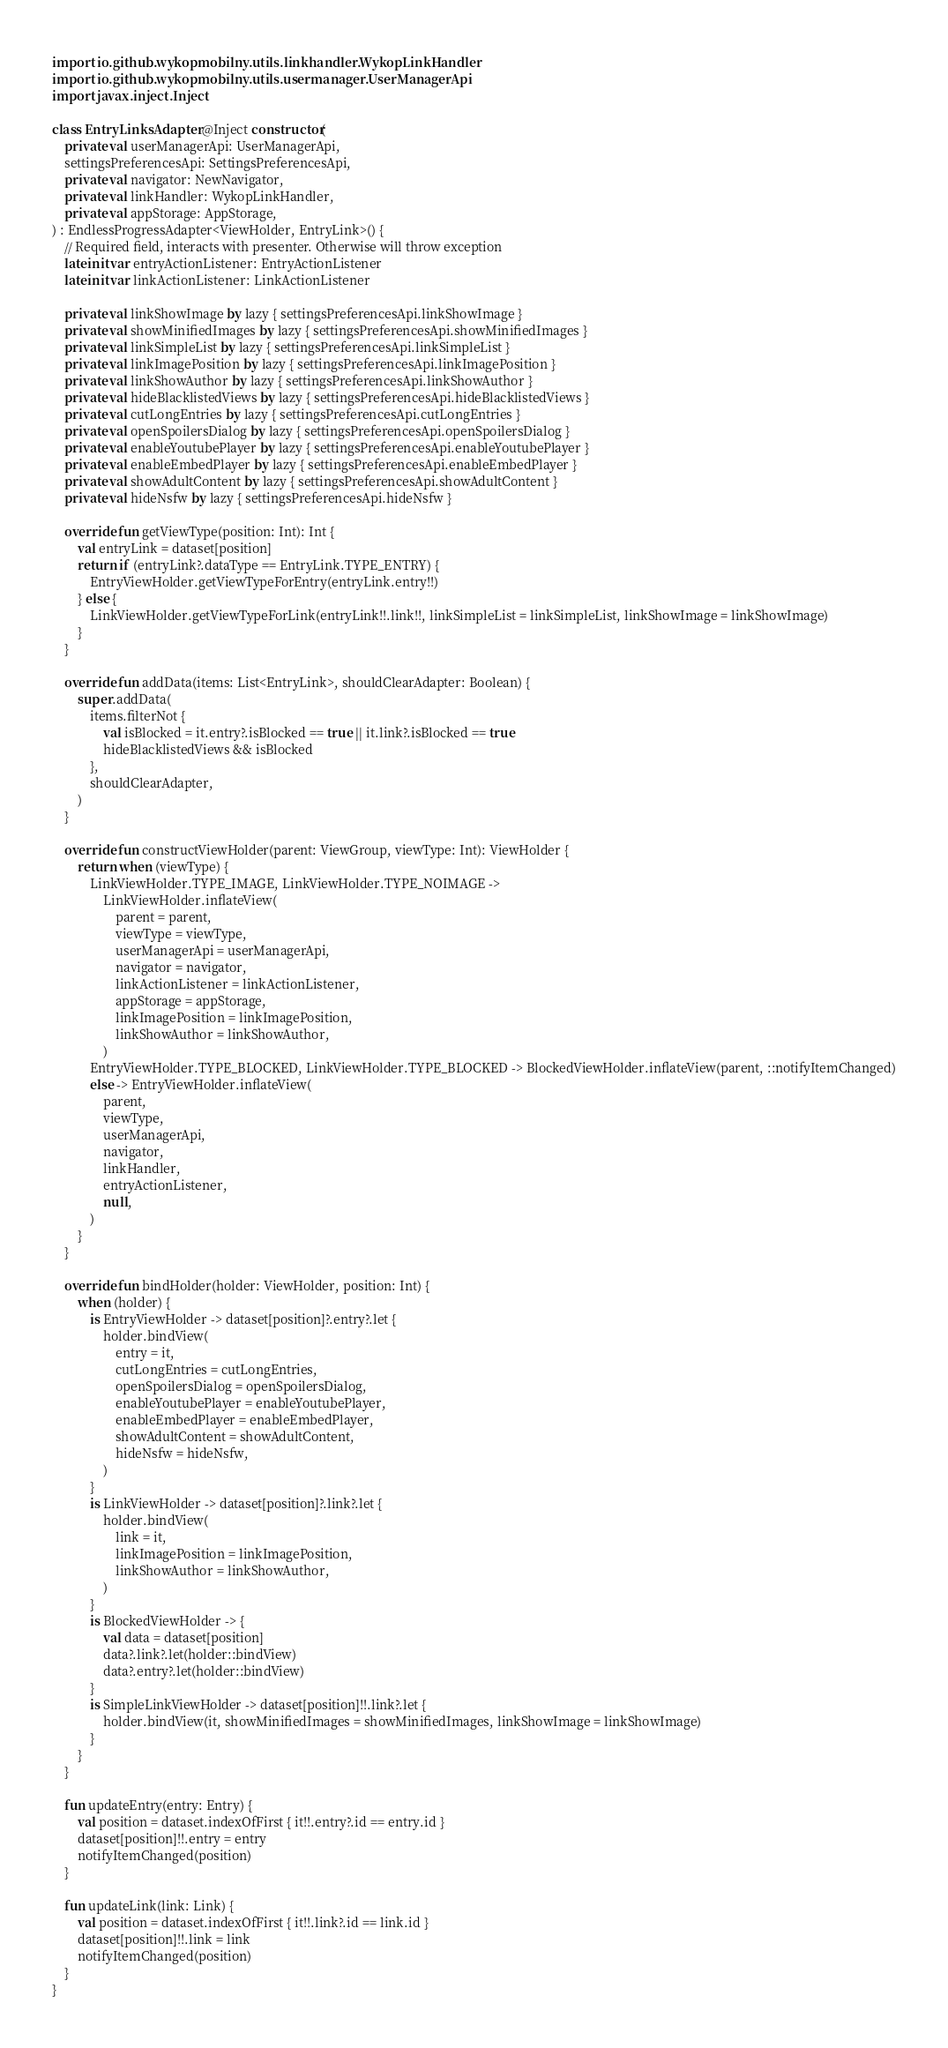Convert code to text. <code><loc_0><loc_0><loc_500><loc_500><_Kotlin_>import io.github.wykopmobilny.utils.linkhandler.WykopLinkHandler
import io.github.wykopmobilny.utils.usermanager.UserManagerApi
import javax.inject.Inject

class EntryLinksAdapter @Inject constructor(
    private val userManagerApi: UserManagerApi,
    settingsPreferencesApi: SettingsPreferencesApi,
    private val navigator: NewNavigator,
    private val linkHandler: WykopLinkHandler,
    private val appStorage: AppStorage,
) : EndlessProgressAdapter<ViewHolder, EntryLink>() {
    // Required field, interacts with presenter. Otherwise will throw exception
    lateinit var entryActionListener: EntryActionListener
    lateinit var linkActionListener: LinkActionListener

    private val linkShowImage by lazy { settingsPreferencesApi.linkShowImage }
    private val showMinifiedImages by lazy { settingsPreferencesApi.showMinifiedImages }
    private val linkSimpleList by lazy { settingsPreferencesApi.linkSimpleList }
    private val linkImagePosition by lazy { settingsPreferencesApi.linkImagePosition }
    private val linkShowAuthor by lazy { settingsPreferencesApi.linkShowAuthor }
    private val hideBlacklistedViews by lazy { settingsPreferencesApi.hideBlacklistedViews }
    private val cutLongEntries by lazy { settingsPreferencesApi.cutLongEntries }
    private val openSpoilersDialog by lazy { settingsPreferencesApi.openSpoilersDialog }
    private val enableYoutubePlayer by lazy { settingsPreferencesApi.enableYoutubePlayer }
    private val enableEmbedPlayer by lazy { settingsPreferencesApi.enableEmbedPlayer }
    private val showAdultContent by lazy { settingsPreferencesApi.showAdultContent }
    private val hideNsfw by lazy { settingsPreferencesApi.hideNsfw }

    override fun getViewType(position: Int): Int {
        val entryLink = dataset[position]
        return if (entryLink?.dataType == EntryLink.TYPE_ENTRY) {
            EntryViewHolder.getViewTypeForEntry(entryLink.entry!!)
        } else {
            LinkViewHolder.getViewTypeForLink(entryLink!!.link!!, linkSimpleList = linkSimpleList, linkShowImage = linkShowImage)
        }
    }

    override fun addData(items: List<EntryLink>, shouldClearAdapter: Boolean) {
        super.addData(
            items.filterNot {
                val isBlocked = it.entry?.isBlocked == true || it.link?.isBlocked == true
                hideBlacklistedViews && isBlocked
            },
            shouldClearAdapter,
        )
    }

    override fun constructViewHolder(parent: ViewGroup, viewType: Int): ViewHolder {
        return when (viewType) {
            LinkViewHolder.TYPE_IMAGE, LinkViewHolder.TYPE_NOIMAGE ->
                LinkViewHolder.inflateView(
                    parent = parent,
                    viewType = viewType,
                    userManagerApi = userManagerApi,
                    navigator = navigator,
                    linkActionListener = linkActionListener,
                    appStorage = appStorage,
                    linkImagePosition = linkImagePosition,
                    linkShowAuthor = linkShowAuthor,
                )
            EntryViewHolder.TYPE_BLOCKED, LinkViewHolder.TYPE_BLOCKED -> BlockedViewHolder.inflateView(parent, ::notifyItemChanged)
            else -> EntryViewHolder.inflateView(
                parent,
                viewType,
                userManagerApi,
                navigator,
                linkHandler,
                entryActionListener,
                null,
            )
        }
    }

    override fun bindHolder(holder: ViewHolder, position: Int) {
        when (holder) {
            is EntryViewHolder -> dataset[position]?.entry?.let {
                holder.bindView(
                    entry = it,
                    cutLongEntries = cutLongEntries,
                    openSpoilersDialog = openSpoilersDialog,
                    enableYoutubePlayer = enableYoutubePlayer,
                    enableEmbedPlayer = enableEmbedPlayer,
                    showAdultContent = showAdultContent,
                    hideNsfw = hideNsfw,
                )
            }
            is LinkViewHolder -> dataset[position]?.link?.let {
                holder.bindView(
                    link = it,
                    linkImagePosition = linkImagePosition,
                    linkShowAuthor = linkShowAuthor,
                )
            }
            is BlockedViewHolder -> {
                val data = dataset[position]
                data?.link?.let(holder::bindView)
                data?.entry?.let(holder::bindView)
            }
            is SimpleLinkViewHolder -> dataset[position]!!.link?.let {
                holder.bindView(it, showMinifiedImages = showMinifiedImages, linkShowImage = linkShowImage)
            }
        }
    }

    fun updateEntry(entry: Entry) {
        val position = dataset.indexOfFirst { it!!.entry?.id == entry.id }
        dataset[position]!!.entry = entry
        notifyItemChanged(position)
    }

    fun updateLink(link: Link) {
        val position = dataset.indexOfFirst { it!!.link?.id == link.id }
        dataset[position]!!.link = link
        notifyItemChanged(position)
    }
}
</code> 